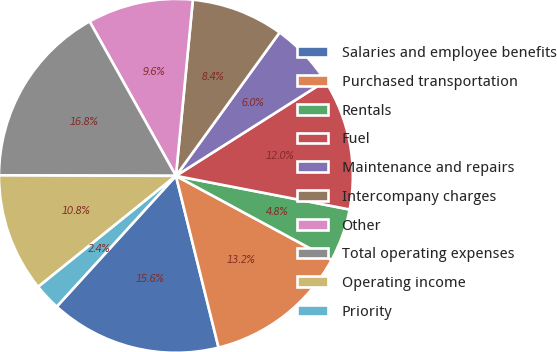<chart> <loc_0><loc_0><loc_500><loc_500><pie_chart><fcel>Salaries and employee benefits<fcel>Purchased transportation<fcel>Rentals<fcel>Fuel<fcel>Maintenance and repairs<fcel>Intercompany charges<fcel>Other<fcel>Total operating expenses<fcel>Operating income<fcel>Priority<nl><fcel>15.64%<fcel>13.24%<fcel>4.84%<fcel>12.04%<fcel>6.04%<fcel>8.44%<fcel>9.64%<fcel>16.84%<fcel>10.84%<fcel>2.44%<nl></chart> 